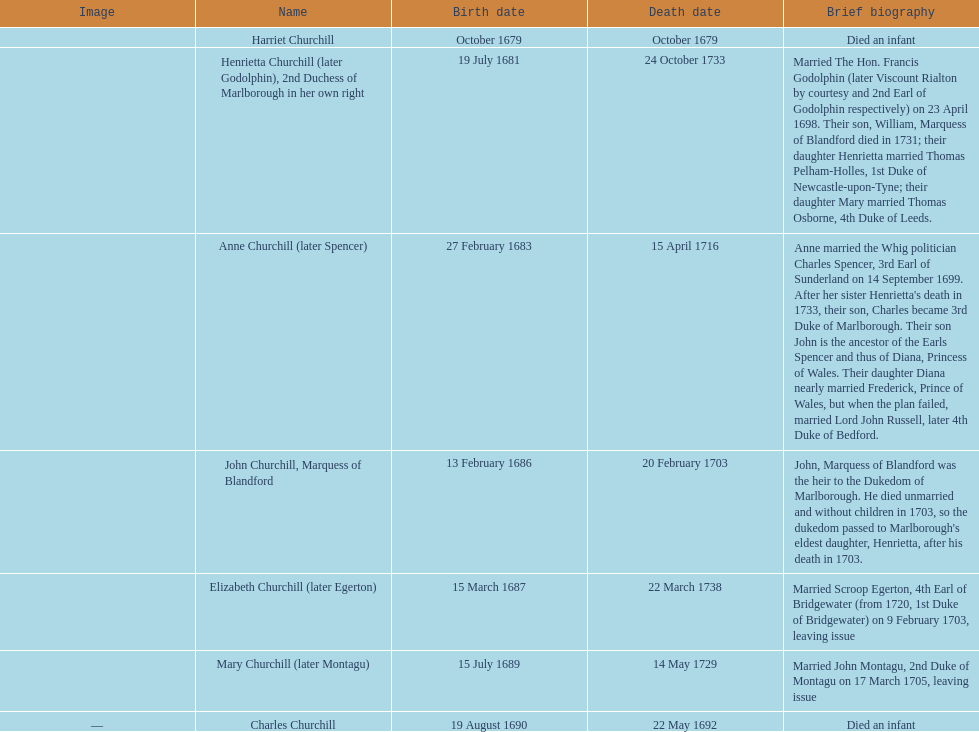The quantity of kids sarah churchill had is? 7. 